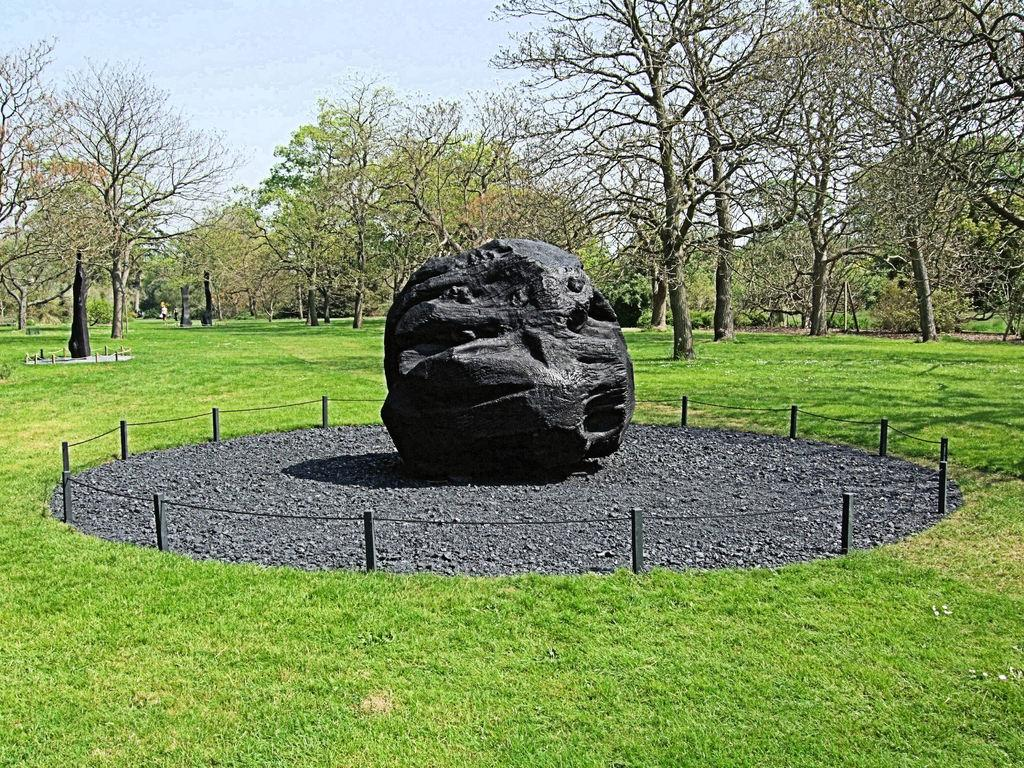What is the main object in the center of the image? There is a rock placed on the ground in the center of the image. What else can be seen in the center of the image? There is a group of poles and cable in the center of the image. What type of vegetation is visible in the background of the image? There is grass and a group of trees visible in the background of the image. What is visible in the background of the image beyond the vegetation? The sky is visible in the background of the image. What type of territory does the rock claim in the image? There is no indication in the image that the rock is claiming any territory. What type of throne is the rock sitting on in the image? There is no throne present in the image; it is a rock placed on the ground. 